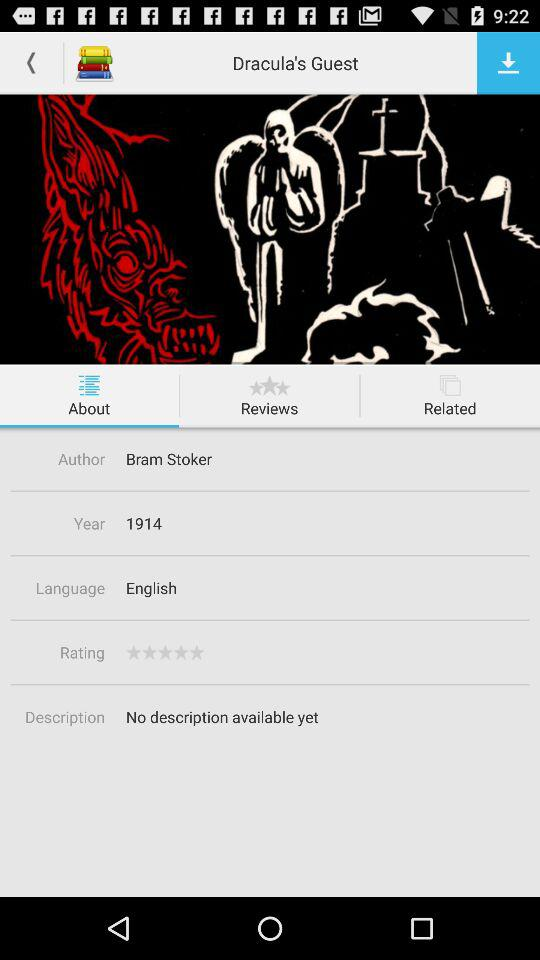What is the description? There is no description available yet. 